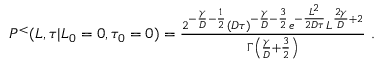Convert formula to latex. <formula><loc_0><loc_0><loc_500><loc_500>\begin{array} { r } { P ^ { < } ( L , \tau | L _ { 0 } = 0 , \tau _ { 0 } = 0 ) = \frac { 2 ^ { - \frac { \gamma } { D } - \frac { 1 } { 2 } } ( D \tau ) ^ { - \frac { \gamma } { D } - \frac { 3 } { 2 } } e ^ { - \frac { L ^ { 2 } } { 2 D \tau } } L ^ { \frac { 2 \gamma } { D } + 2 } } { \Gamma \left ( \frac { \gamma } { D } + \frac { 3 } { 2 } \right ) } \ . } \end{array}</formula> 